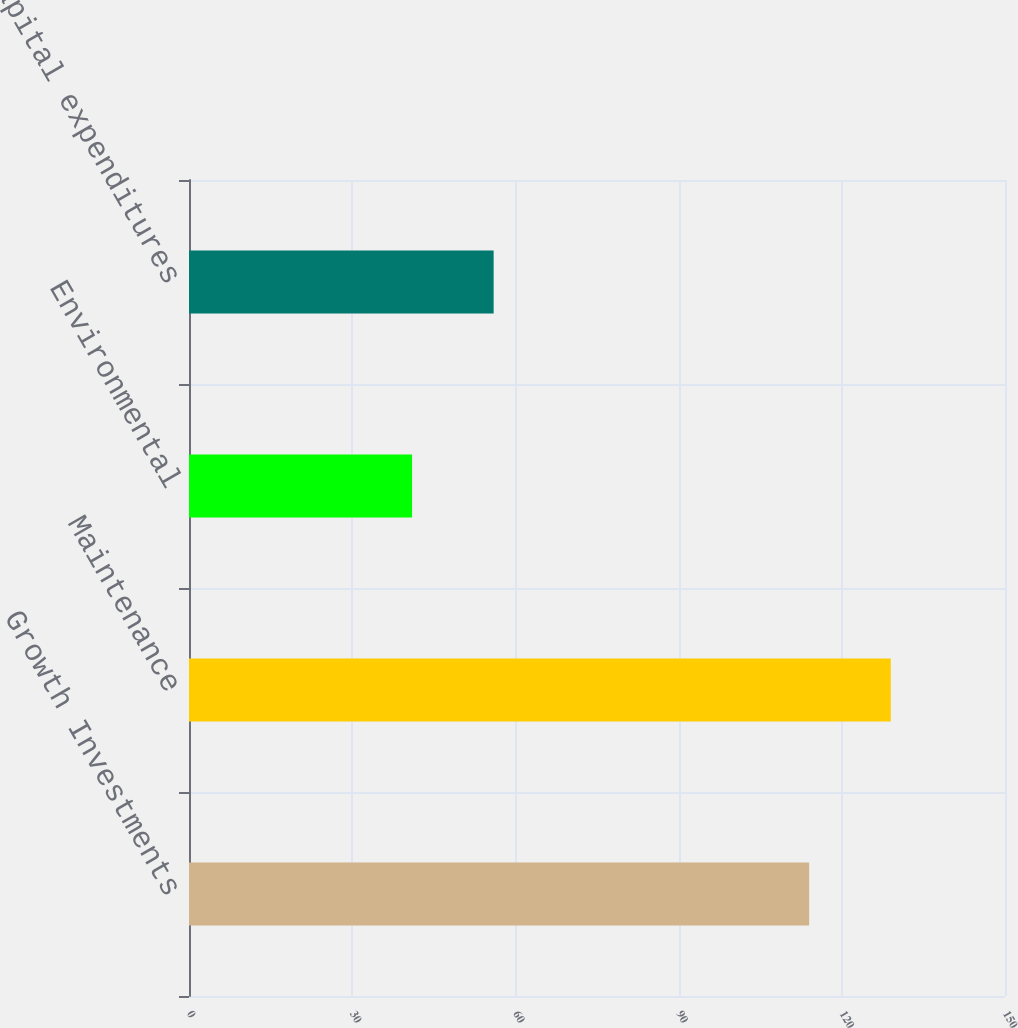<chart> <loc_0><loc_0><loc_500><loc_500><bar_chart><fcel>Growth Investments<fcel>Maintenance<fcel>Environmental<fcel>Total capital expenditures<nl><fcel>114<fcel>129<fcel>41<fcel>56<nl></chart> 